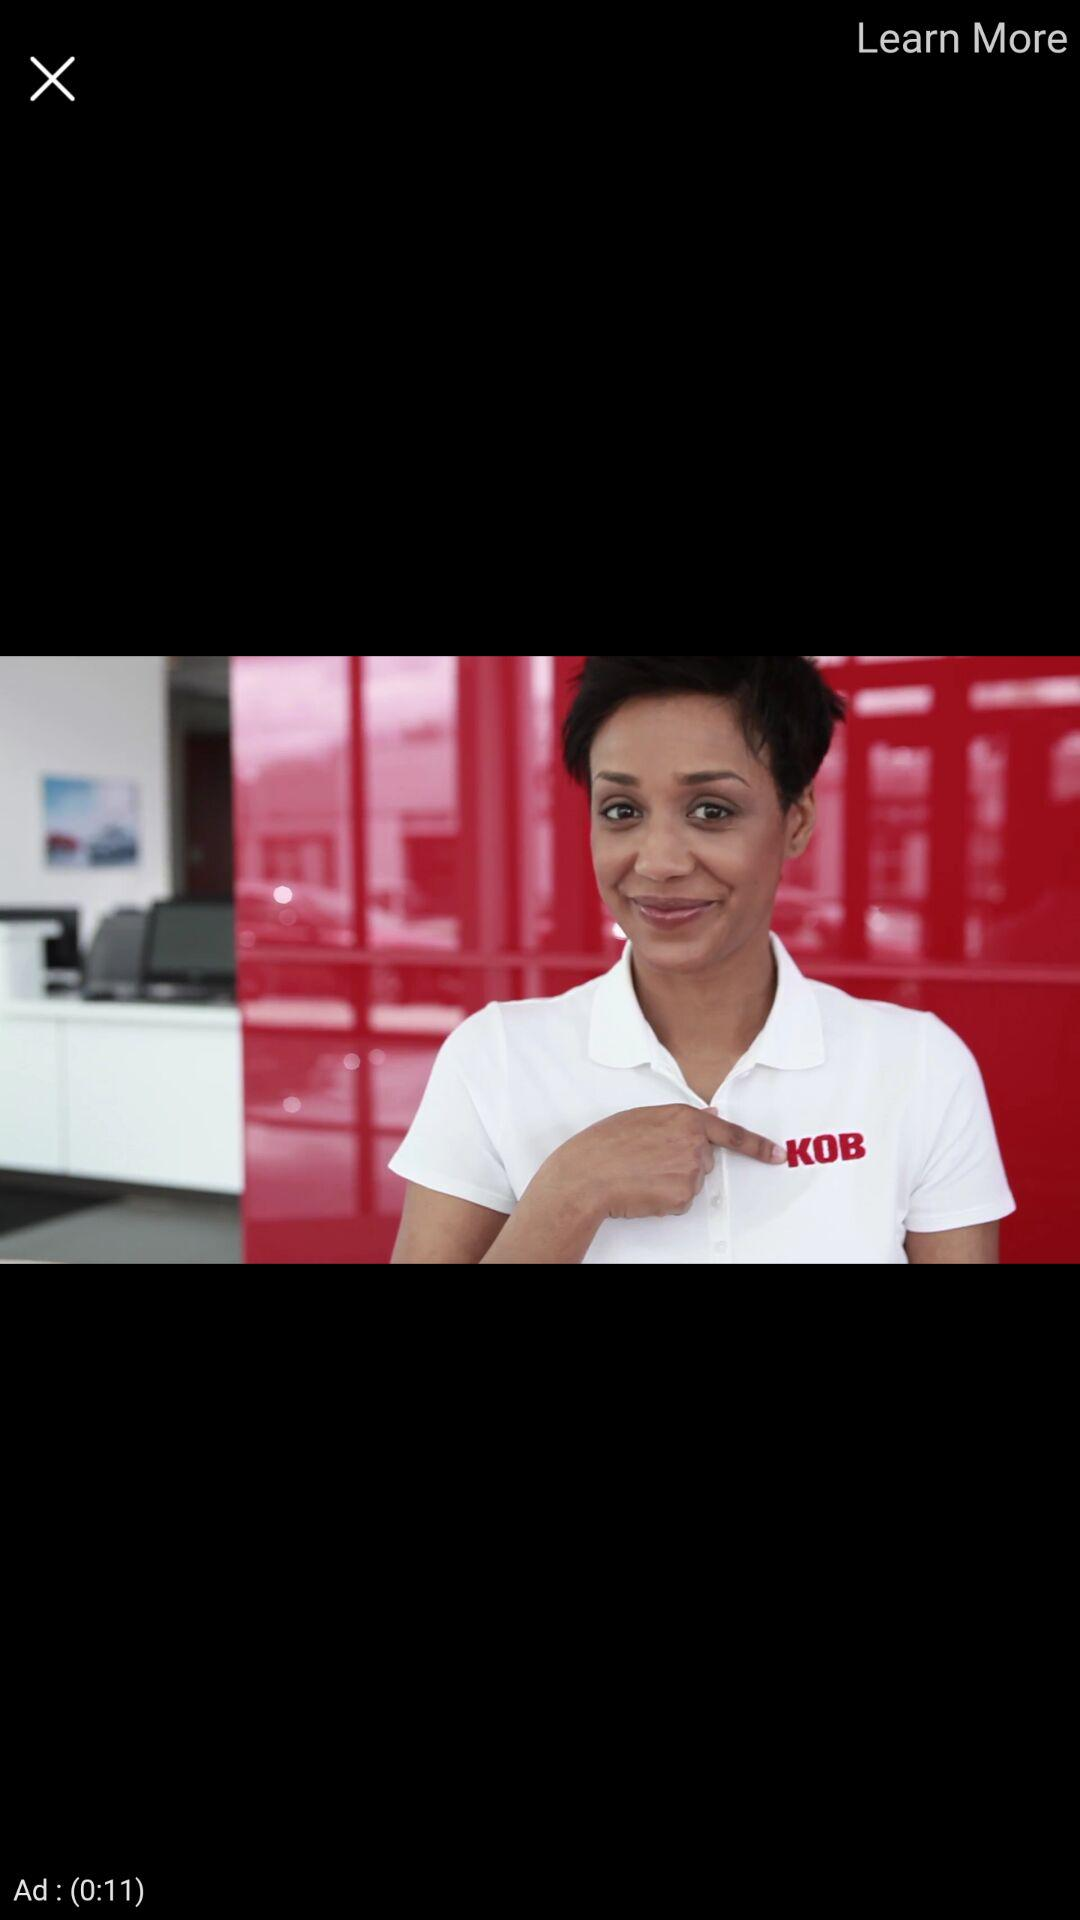How many seconds long is the ad?
Answer the question using a single word or phrase. 11 